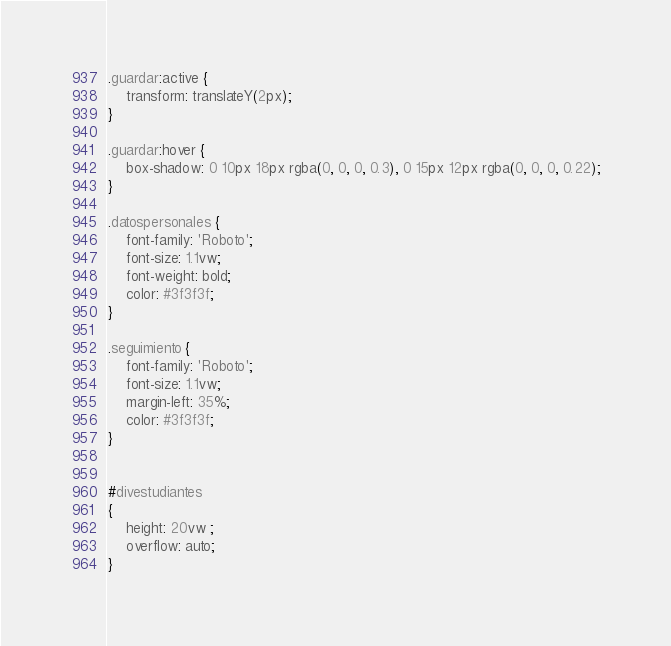Convert code to text. <code><loc_0><loc_0><loc_500><loc_500><_CSS_>
.guardar:active {
	transform: translateY(2px);
}

.guardar:hover {
	box-shadow: 0 10px 18px rgba(0, 0, 0, 0.3), 0 15px 12px rgba(0, 0, 0, 0.22);
}

.datospersonales {
	font-family: 'Roboto';
	font-size: 1.1vw;
	font-weight: bold;
	color: #3f3f3f;
}

.seguimiento {
	font-family: 'Roboto';
	font-size: 1.1vw;
	margin-left: 35%;
	color: #3f3f3f;
}


#divestudiantes
{
	height: 20vw ;
	overflow: auto;
}</code> 